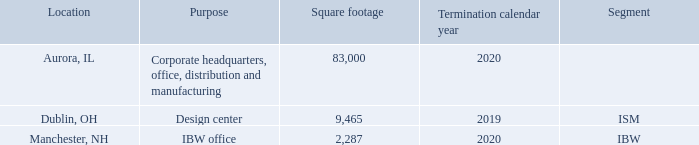ITEM 2. PROPERTIES
The Company leases the following real property:
The Company executed a three-year lease beginning in October 2017 for approximately 83,000 square feet for our Aurora, Illinois headquarters facility.
During fiscal year 2019, the Company executed a two-year lease beginning in September 2018 for approximately 2,300 square feet for our Manchester, New Hampshire IBW office space.
The Company is currently evaluating a replacement lease for the ISM design center in Ohio.
On April 1, 2013, as a result of the Kentrox acquisition, the Company acquired a sixteen acre parcel of land in Dublin, Ohio. The Company sold four acres in April 2015 and is marketing the remaining twelve acres for sale.
When was the start of the lease of the headquarters facility? October 2017. What is the square footage of the real property in Aurora, IL? 83,000. What is the result of the Kentrox acquisition? The company acquired a sixteen acre parcel of land in dublin, ohio. Which location has the biggest square footage?  83,000>9,465>2,287
Answer: aurora, il. What is the total area, in square feet, of the Company’s real property? 83,000+9,465+2,287 
Answer: 94752. Which location has the earliest termination year of its lease? 2019<2020
Answer: dublin, oh. 